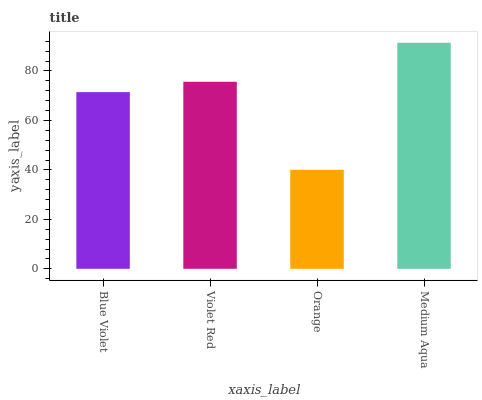Is Orange the minimum?
Answer yes or no. Yes. Is Medium Aqua the maximum?
Answer yes or no. Yes. Is Violet Red the minimum?
Answer yes or no. No. Is Violet Red the maximum?
Answer yes or no. No. Is Violet Red greater than Blue Violet?
Answer yes or no. Yes. Is Blue Violet less than Violet Red?
Answer yes or no. Yes. Is Blue Violet greater than Violet Red?
Answer yes or no. No. Is Violet Red less than Blue Violet?
Answer yes or no. No. Is Violet Red the high median?
Answer yes or no. Yes. Is Blue Violet the low median?
Answer yes or no. Yes. Is Blue Violet the high median?
Answer yes or no. No. Is Violet Red the low median?
Answer yes or no. No. 